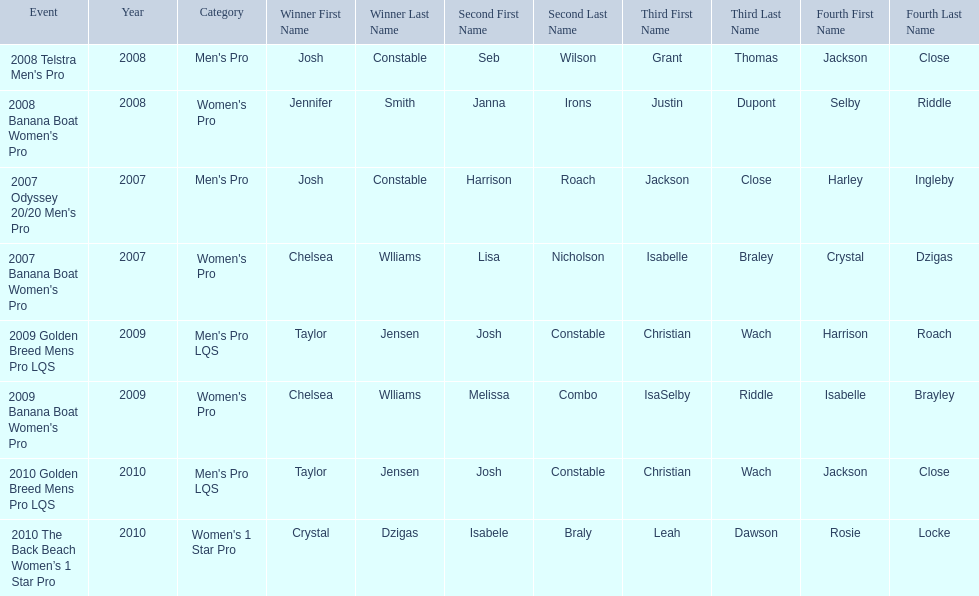What is the total number of times chelsea williams was the winner between 2007 and 2010? 2. 